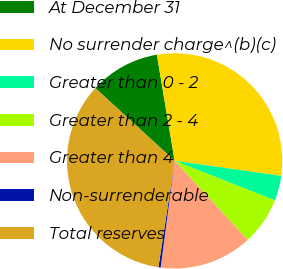Convert chart. <chart><loc_0><loc_0><loc_500><loc_500><pie_chart><fcel>At December 31<fcel>No surrender charge^(b)(c)<fcel>Greater than 0 - 2<fcel>Greater than 2 - 4<fcel>Greater than 4<fcel>Non-surrenderable<fcel>Total reserves<nl><fcel>10.55%<fcel>29.88%<fcel>3.74%<fcel>7.15%<fcel>13.96%<fcel>0.33%<fcel>34.4%<nl></chart> 